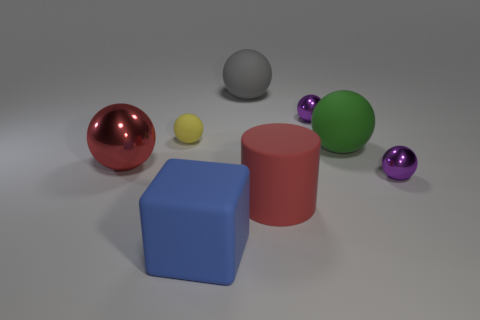Subtract 1 balls. How many balls are left? 5 Subtract all green spheres. How many spheres are left? 5 Subtract all green balls. How many balls are left? 5 Subtract all cyan balls. Subtract all purple cylinders. How many balls are left? 6 Add 2 large green metal spheres. How many objects exist? 10 Subtract all blocks. How many objects are left? 7 Add 6 big brown rubber cylinders. How many big brown rubber cylinders exist? 6 Subtract 0 brown cubes. How many objects are left? 8 Subtract all red metallic things. Subtract all large green rubber objects. How many objects are left? 6 Add 8 large gray matte things. How many large gray matte things are left? 9 